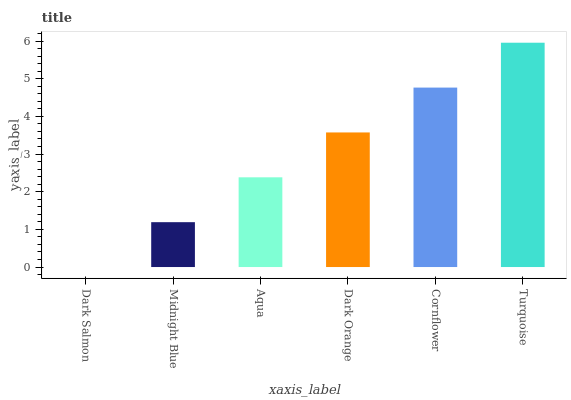Is Dark Salmon the minimum?
Answer yes or no. Yes. Is Turquoise the maximum?
Answer yes or no. Yes. Is Midnight Blue the minimum?
Answer yes or no. No. Is Midnight Blue the maximum?
Answer yes or no. No. Is Midnight Blue greater than Dark Salmon?
Answer yes or no. Yes. Is Dark Salmon less than Midnight Blue?
Answer yes or no. Yes. Is Dark Salmon greater than Midnight Blue?
Answer yes or no. No. Is Midnight Blue less than Dark Salmon?
Answer yes or no. No. Is Dark Orange the high median?
Answer yes or no. Yes. Is Aqua the low median?
Answer yes or no. Yes. Is Cornflower the high median?
Answer yes or no. No. Is Midnight Blue the low median?
Answer yes or no. No. 